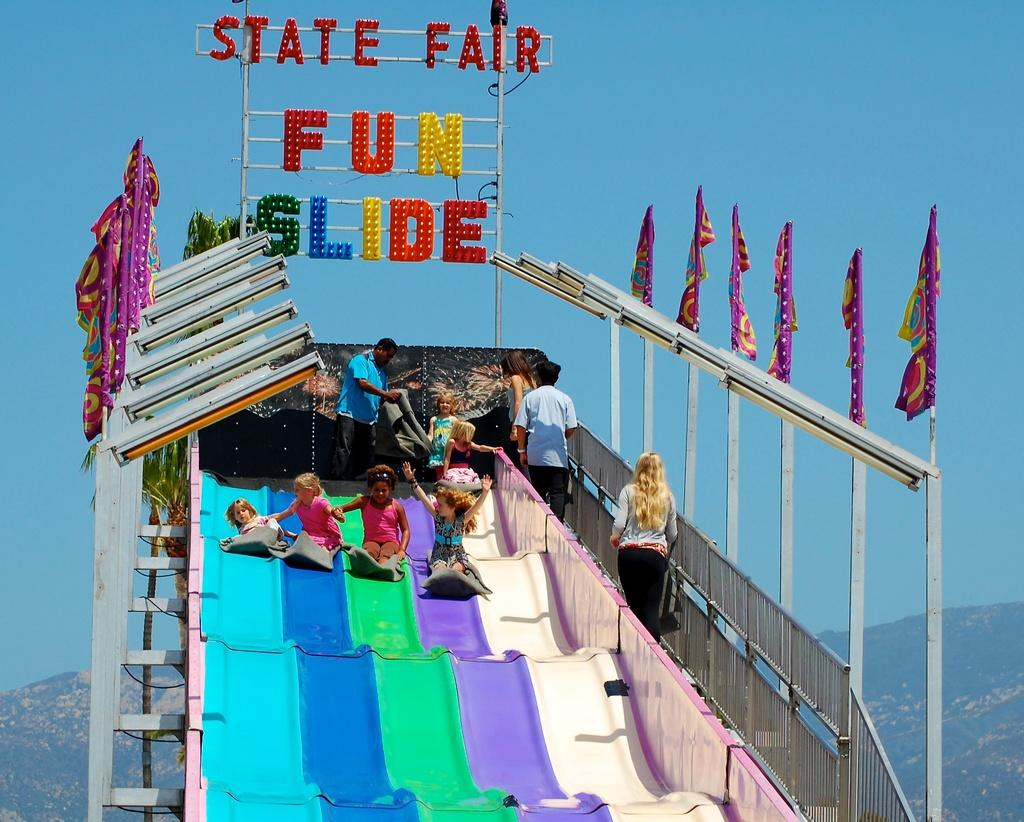What is the main feature in the image? There is a fun slide in the image. Who is using the fun slide? There are kids on the fun slide. Can you describe the people in the image? There are people in the image. What decorations can be seen in the image? There are flags in the image. What natural features are visible in the background of the image? There are mountains, trees, and the sky visible in the background of the image. What type of noise is the chicken making in the image? There is no chicken present in the image, so it is not possible to determine what noise it might be making. 